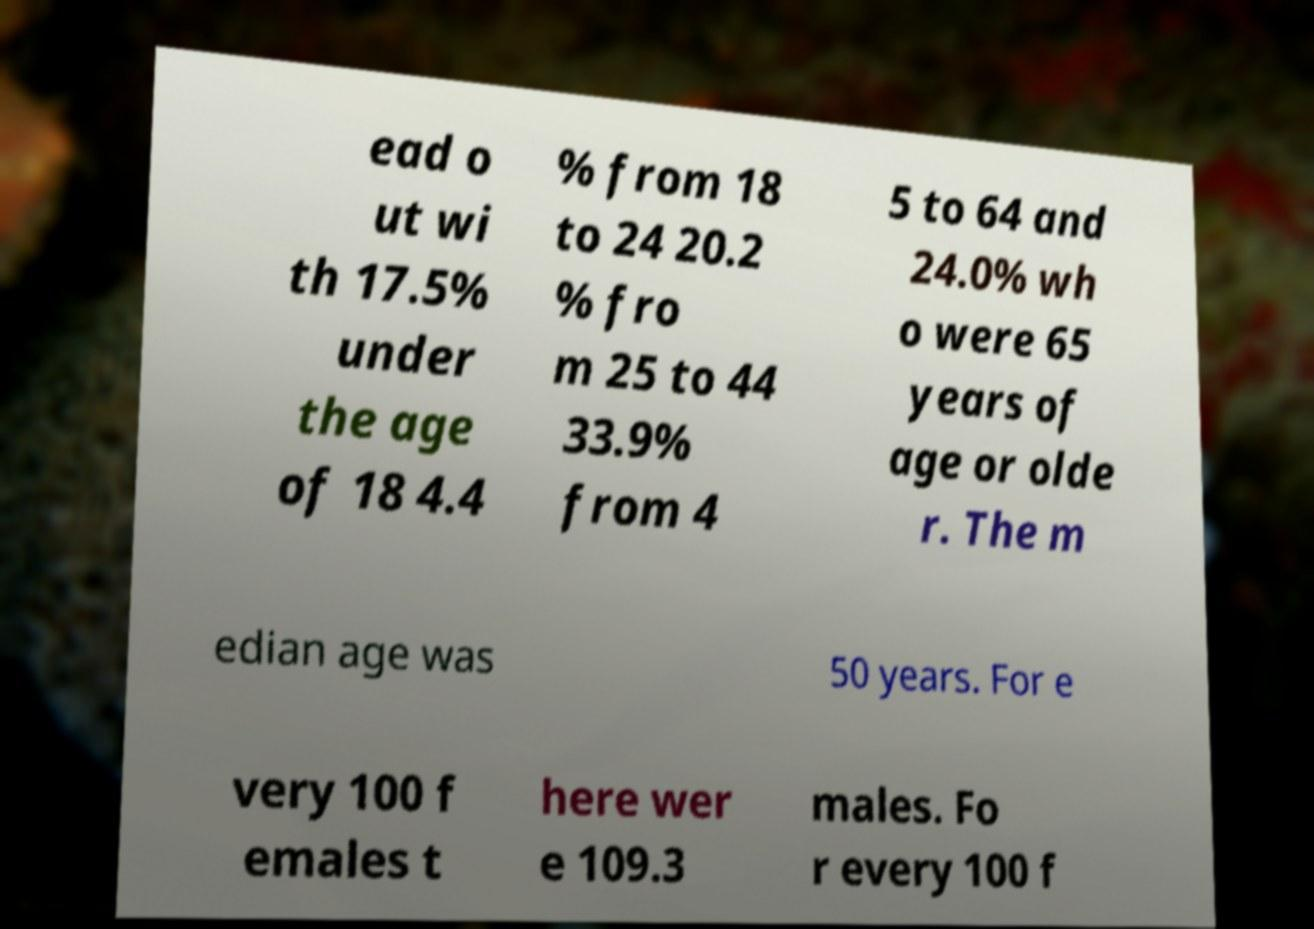Can you accurately transcribe the text from the provided image for me? ead o ut wi th 17.5% under the age of 18 4.4 % from 18 to 24 20.2 % fro m 25 to 44 33.9% from 4 5 to 64 and 24.0% wh o were 65 years of age or olde r. The m edian age was 50 years. For e very 100 f emales t here wer e 109.3 males. Fo r every 100 f 